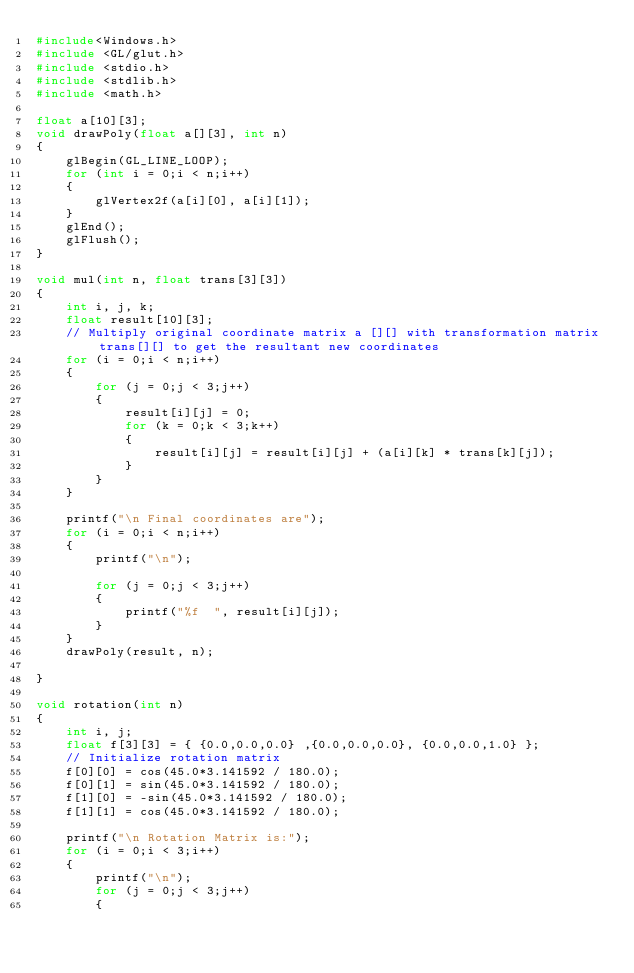<code> <loc_0><loc_0><loc_500><loc_500><_C_>#include<Windows.h>
#include <GL/glut.h>
#include <stdio.h>
#include <stdlib.h>
#include <math.h>

float a[10][3];
void drawPoly(float a[][3], int n)
{
	glBegin(GL_LINE_LOOP);
	for (int i = 0;i < n;i++)
	{
		glVertex2f(a[i][0], a[i][1]);
	}
	glEnd();
	glFlush();
}

void mul(int n, float trans[3][3])
{
	int i, j, k;
	float result[10][3];
	// Multiply original coordinate matrix a [][] with transformation matrix trans[][] to get the resultant new coordinates
	for (i = 0;i < n;i++)
	{
		for (j = 0;j < 3;j++)
		{
			result[i][j] = 0;
			for (k = 0;k < 3;k++)
			{
				result[i][j] = result[i][j] + (a[i][k] * trans[k][j]);
			}
		}
	}

	printf("\n Final coordinates are");
	for (i = 0;i < n;i++)
	{
		printf("\n");

		for (j = 0;j < 3;j++)
		{
			printf("%f  ", result[i][j]);
		}
	}
	drawPoly(result, n);

}

void rotation(int n)
{
	int i, j;
	float f[3][3] = { {0.0,0.0,0.0} ,{0.0,0.0,0.0}, {0.0,0.0,1.0} };
	// Initialize rotation matrix
	f[0][0] = cos(45.0*3.141592 / 180.0);
	f[0][1] = sin(45.0*3.141592 / 180.0);
	f[1][0] = -sin(45.0*3.141592 / 180.0);
	f[1][1] = cos(45.0*3.141592 / 180.0);

	printf("\n Rotation Matrix is:");
	for (i = 0;i < 3;i++)
	{
		printf("\n");
		for (j = 0;j < 3;j++)
		{</code> 